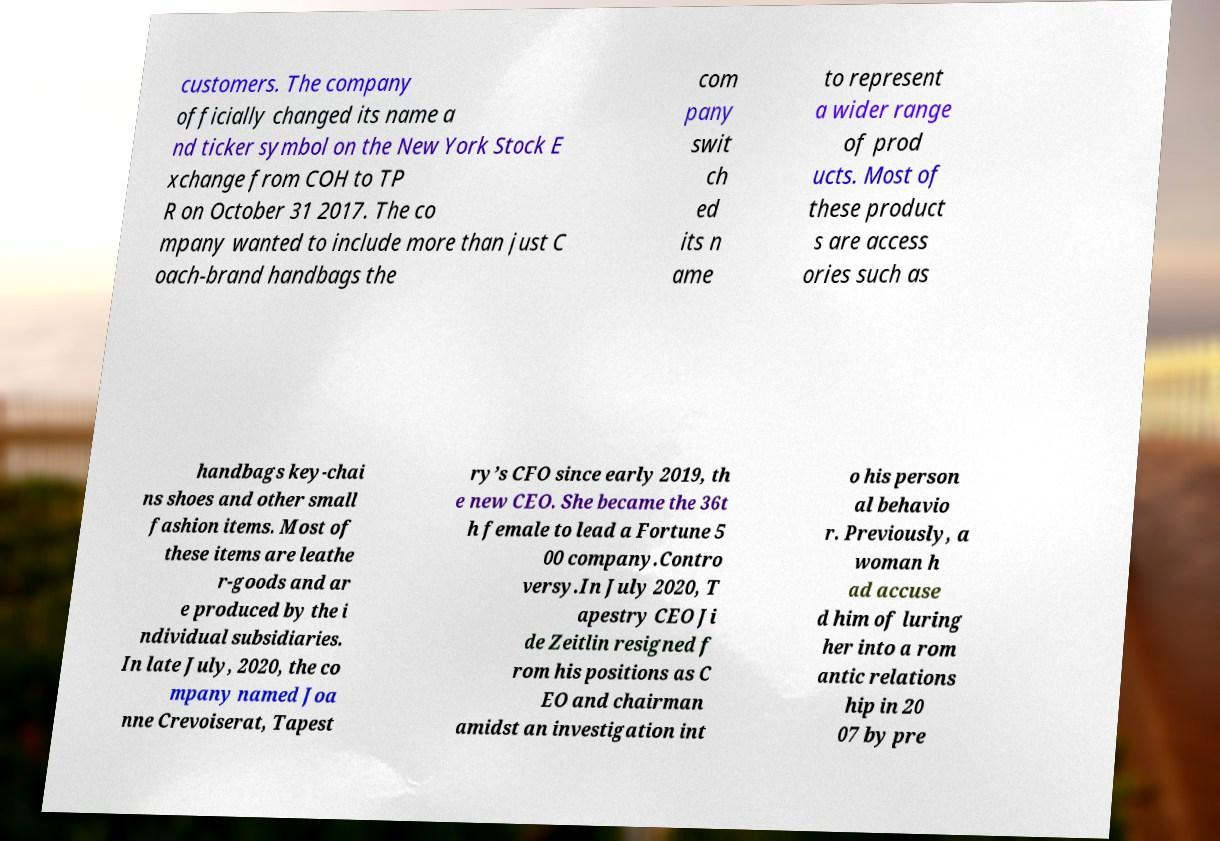Can you read and provide the text displayed in the image?This photo seems to have some interesting text. Can you extract and type it out for me? customers. The company officially changed its name a nd ticker symbol on the New York Stock E xchange from COH to TP R on October 31 2017. The co mpany wanted to include more than just C oach-brand handbags the com pany swit ch ed its n ame to represent a wider range of prod ucts. Most of these product s are access ories such as handbags key-chai ns shoes and other small fashion items. Most of these items are leathe r-goods and ar e produced by the i ndividual subsidiaries. In late July, 2020, the co mpany named Joa nne Crevoiserat, Tapest ry’s CFO since early 2019, th e new CEO. She became the 36t h female to lead a Fortune 5 00 company.Contro versy.In July 2020, T apestry CEO Ji de Zeitlin resigned f rom his positions as C EO and chairman amidst an investigation int o his person al behavio r. Previously, a woman h ad accuse d him of luring her into a rom antic relations hip in 20 07 by pre 